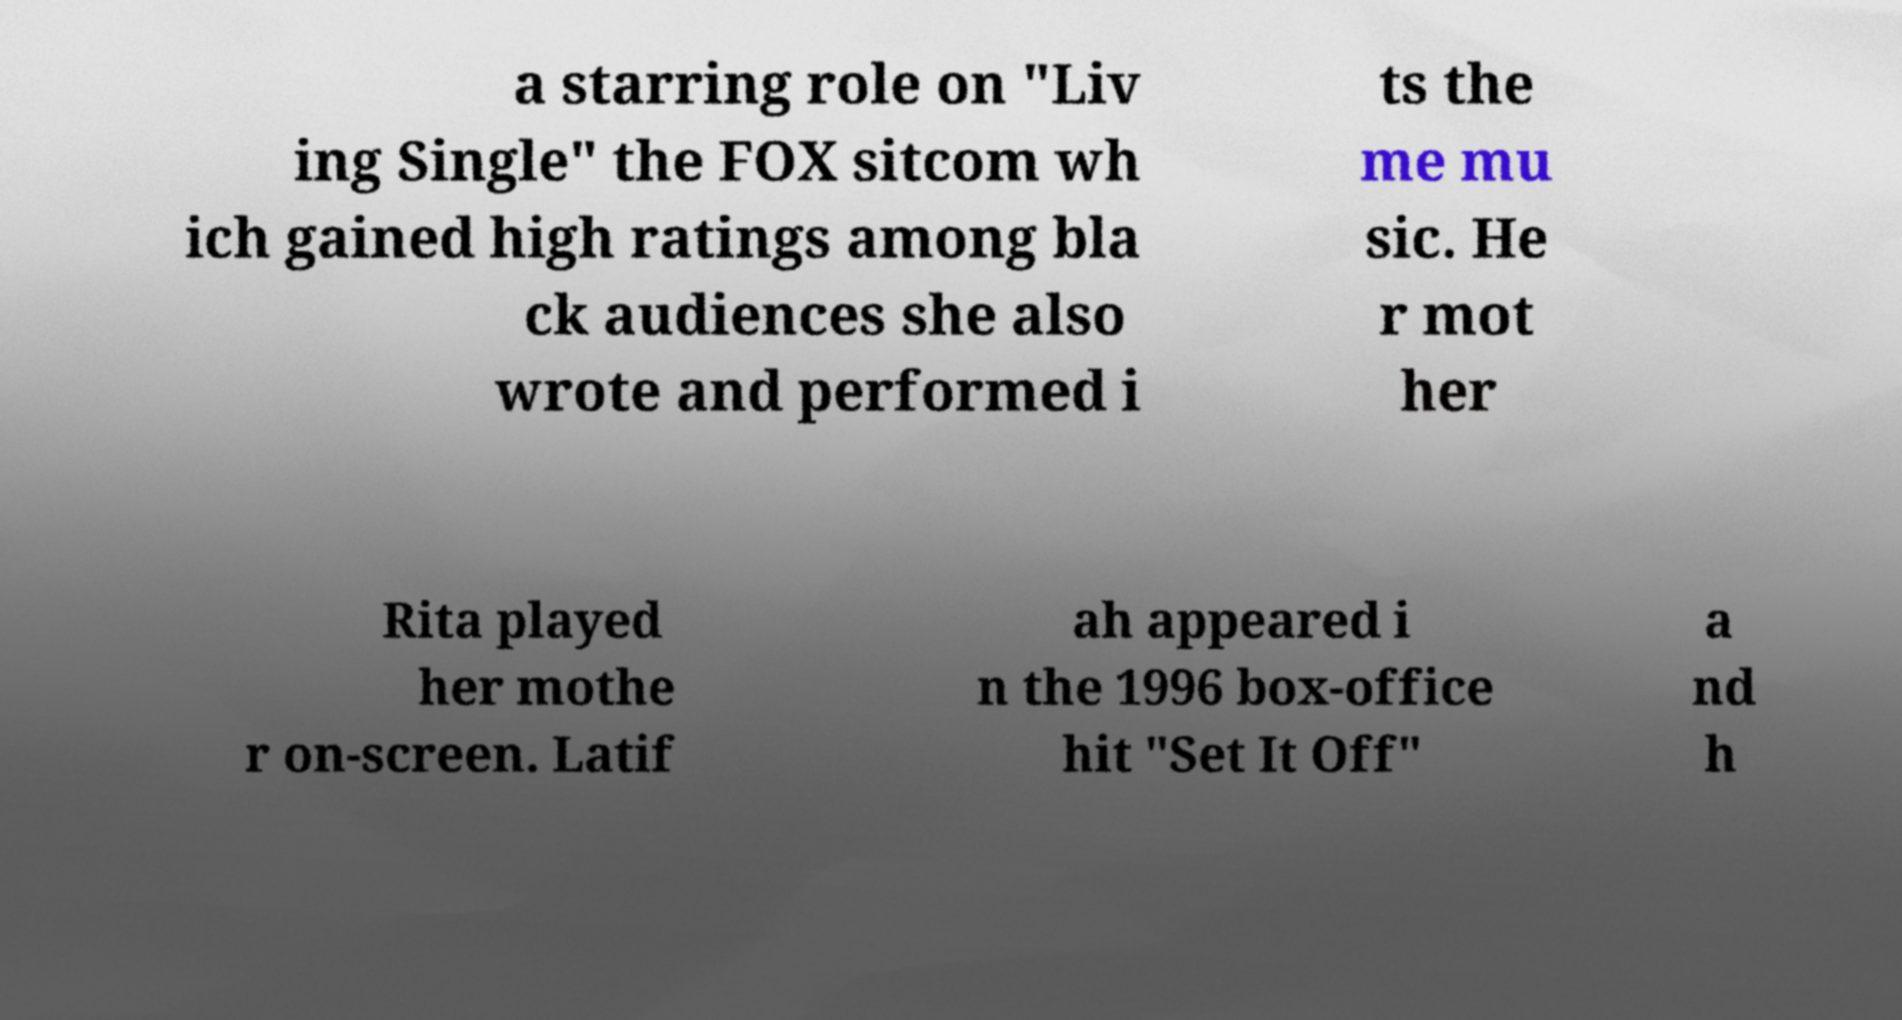Could you assist in decoding the text presented in this image and type it out clearly? a starring role on "Liv ing Single" the FOX sitcom wh ich gained high ratings among bla ck audiences she also wrote and performed i ts the me mu sic. He r mot her Rita played her mothe r on-screen. Latif ah appeared i n the 1996 box-office hit "Set It Off" a nd h 